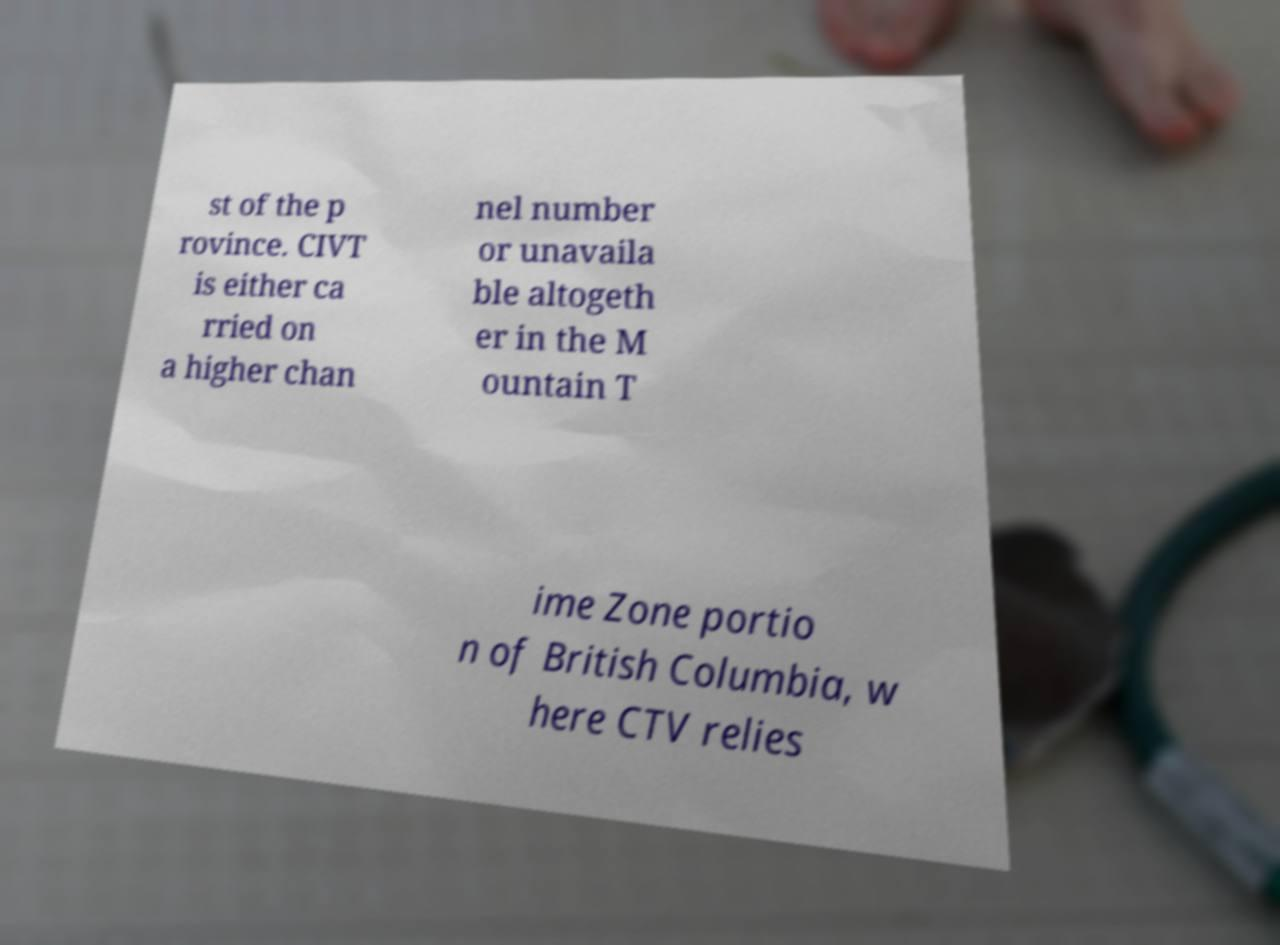There's text embedded in this image that I need extracted. Can you transcribe it verbatim? st of the p rovince. CIVT is either ca rried on a higher chan nel number or unavaila ble altogeth er in the M ountain T ime Zone portio n of British Columbia, w here CTV relies 